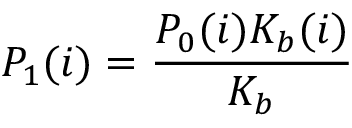Convert formula to latex. <formula><loc_0><loc_0><loc_500><loc_500>P _ { 1 } ( i ) = \frac { P _ { 0 } ( i ) K _ { b } ( i ) } { K _ { b } }</formula> 